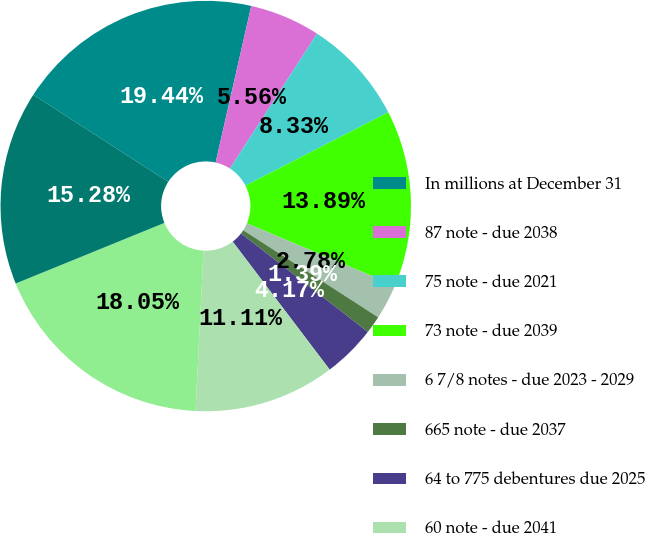<chart> <loc_0><loc_0><loc_500><loc_500><pie_chart><fcel>In millions at December 31<fcel>87 note - due 2038<fcel>75 note - due 2021<fcel>73 note - due 2039<fcel>6 7/8 notes - due 2023 - 2029<fcel>665 note - due 2037<fcel>64 to 775 debentures due 2025<fcel>60 note - due 2041<fcel>500 to 515 notes - due 2035 -<fcel>48 note - due 2044<nl><fcel>19.44%<fcel>5.56%<fcel>8.33%<fcel>13.89%<fcel>2.78%<fcel>1.39%<fcel>4.17%<fcel>11.11%<fcel>18.05%<fcel>15.28%<nl></chart> 